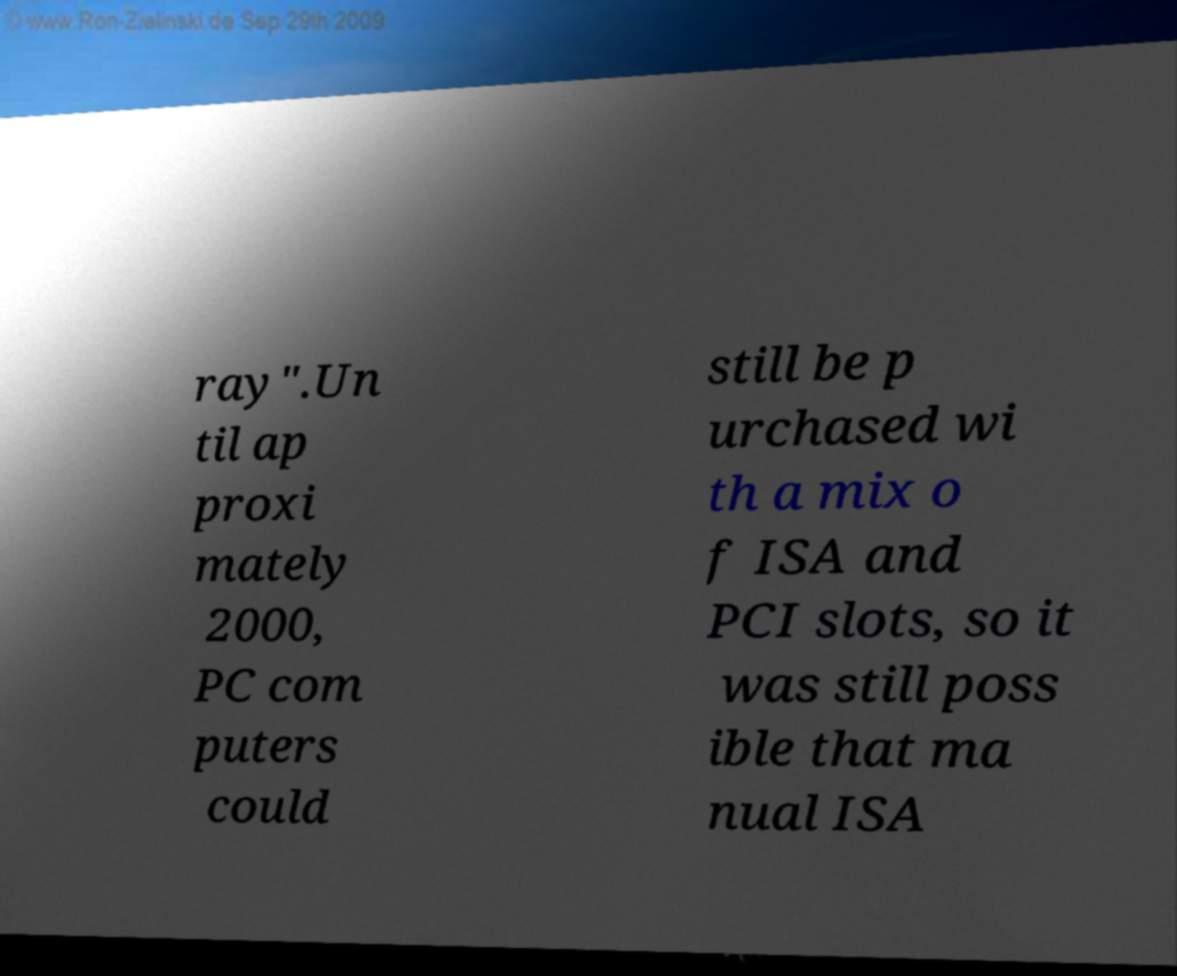Can you accurately transcribe the text from the provided image for me? ray".Un til ap proxi mately 2000, PC com puters could still be p urchased wi th a mix o f ISA and PCI slots, so it was still poss ible that ma nual ISA 